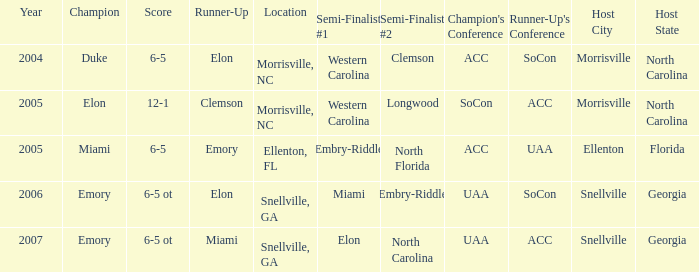List the scores of all games when Miami were listed as the first Semi finalist 6-5 ot. 